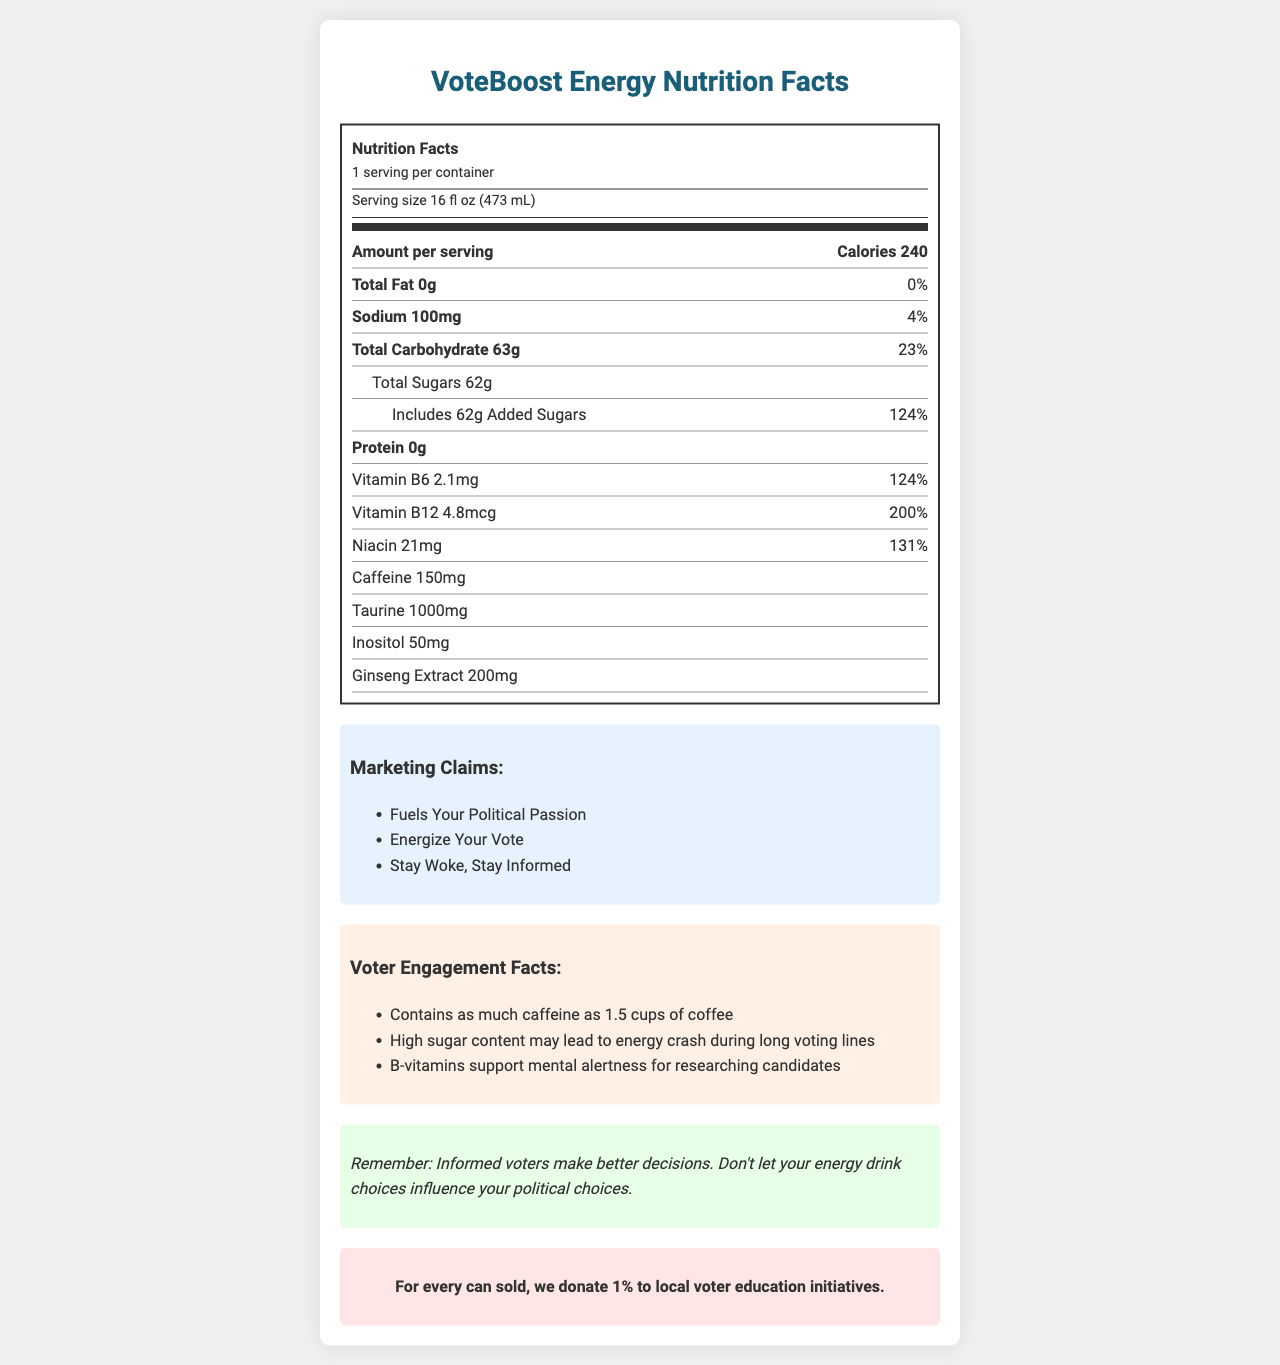how many calories are in a serving of VoteBoost Energy? The document states that each serving of VoteBoost Energy contains 240 calories.
Answer: 240 What is the serving size for VoteBoost Energy? The serving size is listed as 16 fluid ounces (473 milliliters) on the document.
Answer: 16 fl oz (473 mL) How much sodium is in VoteBoost Energy? The document specifies that VoteBoost Energy contains 100 mg of sodium per serving.
Answer: 100mg Which vitamin is present in the highest daily value percentage? A. Vitamin B6 B. Vitamin B12 C. Niacin The document states that Niacin has a 131% daily value, which is higher than Vitamin B6 (124%) and Vitamin B12 (200%).
Answer: C. Niacin What is the primary ingredient that promotes mental alertness? The document lists B-vitamins, including Vitamin B6 and B12, which support mental alertness for researching candidates.
Answer: B-vitamins Does VoteBoost Energy contain any protein? The document indicates that VoteBoost Energy contains 0g of protein.
Answer: No What amount of total sugars does VoteBoost Energy have? The document shows that VoteBoost Energy contains 62 grams of total sugars.
Answer: 62g How much caffeine is in VoteBoost Energy? The document lists 150 mg of caffeine as part of the product's ingredients.
Answer: 150mg What does the community impact statement say about each purchase? The community impact statement is listed as "For every can sold, we donate 1% to local voter education initiatives."
Answer: For every can sold, we donate 1% to local voter education initiatives. Name a marketing claim made by VoteBoost Energy. One of the marketing claims listed is "Fuels Your Political Passion."
Answer: Fuels Your Political Passion What is the main idea of the political awareness note in the document? The political awareness note emphasizes the importance of being informed and not letting the energy drink influence political decisions.
Answer: Informed voters make better decisions; don't let your energy drink choices influence your political choices. What should you remember according to the document's political awareness note? The document's political awareness note reminds readers that informed voters make better decisions.
Answer: Informed voters make better decisions. Why might the high sugar content be a concern according to the voter engagement facts? The document states that high sugar content can lead to an energy crash during long voting lines, which can impact voter endurance.
Answer: High sugar content may lead to an energy crash during long voting lines What special ingredients are present in VoteBoost Energy besides vitamins and caffeine? The document mentions that VoteBoost Energy contains Taurine, Inositol, and Ginseng Extract.
Answer: Taurine, Inositol, Ginseng Extract What percentage of daily value does Vitamin B12 in VoteBoost Energy provide? The document indicates that Vitamin B12 provides 200% of the daily value.
Answer: 200% What is the total carbohydrate content in VoteBoost Energy? The document shows that the total carbohydrate content in VoteBoost Energy is 63 grams.
Answer: 63g Does VoteBoost Energy contain any fat? The document lists the total fat content as 0g, meaning there is no fat.
Answer: No What might happen if you drink VoteBoost Energy before a long voting session? According to the voter engagement facts, the high sugar content may lead to an energy crash during long voting lines.
Answer: You might experience an energy crash due to the high sugar content. What is the aim of VoteBoost Energy's community impact initiative? The community impact statement indicates that 1% of every can sold goes towards local voter education initiatives.
Answer: To support local voter education initiatives. How does VoteBoost Energy help support mental alertness? The document mentions that B-vitamins support mental alertness for researching candidates.
Answer: Through B-vitamins like Vitamin B6 and Vitamin B12. How much Taurine is in VoteBoost Energy? The document specifies that VoteBoost Energy contains 1000 mg of Taurine.
Answer: 1000mg What is the message promoted by the marketing claims of VoteBoost Energy? The marketing claims convey a message of energizing the voter and promoting political passion and informed voting.
Answer: To energize and fuel political passion while staying informed. Can you determine the flavor of VoteBoost Energy from the document? The document does not contain any information about the flavor of VoteBoost Energy.
Answer: Cannot be determined 